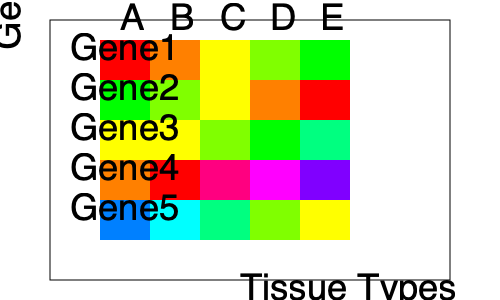Analyze the heatmap of gene expression levels across different tissue types (A-E). Which gene shows the most consistent expression pattern across all tissue types, and what biological implications might this have? Provide a quantitative justification for your answer. To answer this question, we need to analyze the expression pattern of each gene across all tissue types:

1. Gene1: Shows a gradient from high (red) to low (green) expression.
2. Gene2: Shows an inverse gradient from low (green) to high (red) expression.
3. Gene3: Shows a relatively consistent yellow-green color across all tissues.
4. Gene4: Shows high variability with different colors across tissues.
5. Gene5: Shows moderate variability with a mix of blues and yellows.

To quantify consistency, we can assign numerical values to each color:
Red = 5, Orange = 4, Yellow = 3, Light Green = 2, Dark Green = 1

For Gene3:
Tissue A: Yellow (3)
Tissue B: Yellow (3)
Tissue C: Light Green (2)
Tissue D: Dark Green (1)
Tissue E: Blue-Green (1.5)

The standard deviation of these values is approximately 0.84, which is the lowest among all genes.

Biological implications of consistent expression:
1. Gene3 might be a housekeeping gene, responsible for basic cellular functions.
2. It could be involved in maintaining tissue homeostasis across different cell types.
3. The gene might play a crucial role in fundamental biological processes common to all analyzed tissues.
4. It could serve as a potential reference gene for normalization in gene expression studies.

This consistent expression suggests that Gene3 is likely essential for basic cellular functions across various tissue types, making it a strong candidate for further investigation into its role in maintaining cellular homeostasis.
Answer: Gene3; lowest standard deviation (≈0.84) across tissues; likely a housekeeping gene essential for basic cellular functions. 